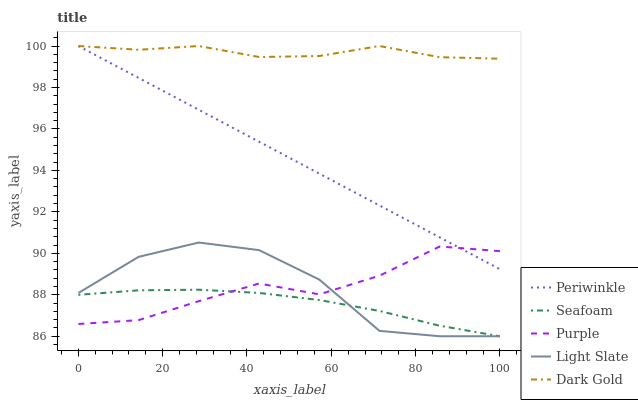Does Seafoam have the minimum area under the curve?
Answer yes or no. Yes. Does Dark Gold have the maximum area under the curve?
Answer yes or no. Yes. Does Light Slate have the minimum area under the curve?
Answer yes or no. No. Does Light Slate have the maximum area under the curve?
Answer yes or no. No. Is Periwinkle the smoothest?
Answer yes or no. Yes. Is Light Slate the roughest?
Answer yes or no. Yes. Is Light Slate the smoothest?
Answer yes or no. No. Is Periwinkle the roughest?
Answer yes or no. No. Does Periwinkle have the lowest value?
Answer yes or no. No. Does Dark Gold have the highest value?
Answer yes or no. Yes. Does Light Slate have the highest value?
Answer yes or no. No. Is Seafoam less than Dark Gold?
Answer yes or no. Yes. Is Periwinkle greater than Seafoam?
Answer yes or no. Yes. Does Periwinkle intersect Purple?
Answer yes or no. Yes. Is Periwinkle less than Purple?
Answer yes or no. No. Is Periwinkle greater than Purple?
Answer yes or no. No. Does Seafoam intersect Dark Gold?
Answer yes or no. No. 